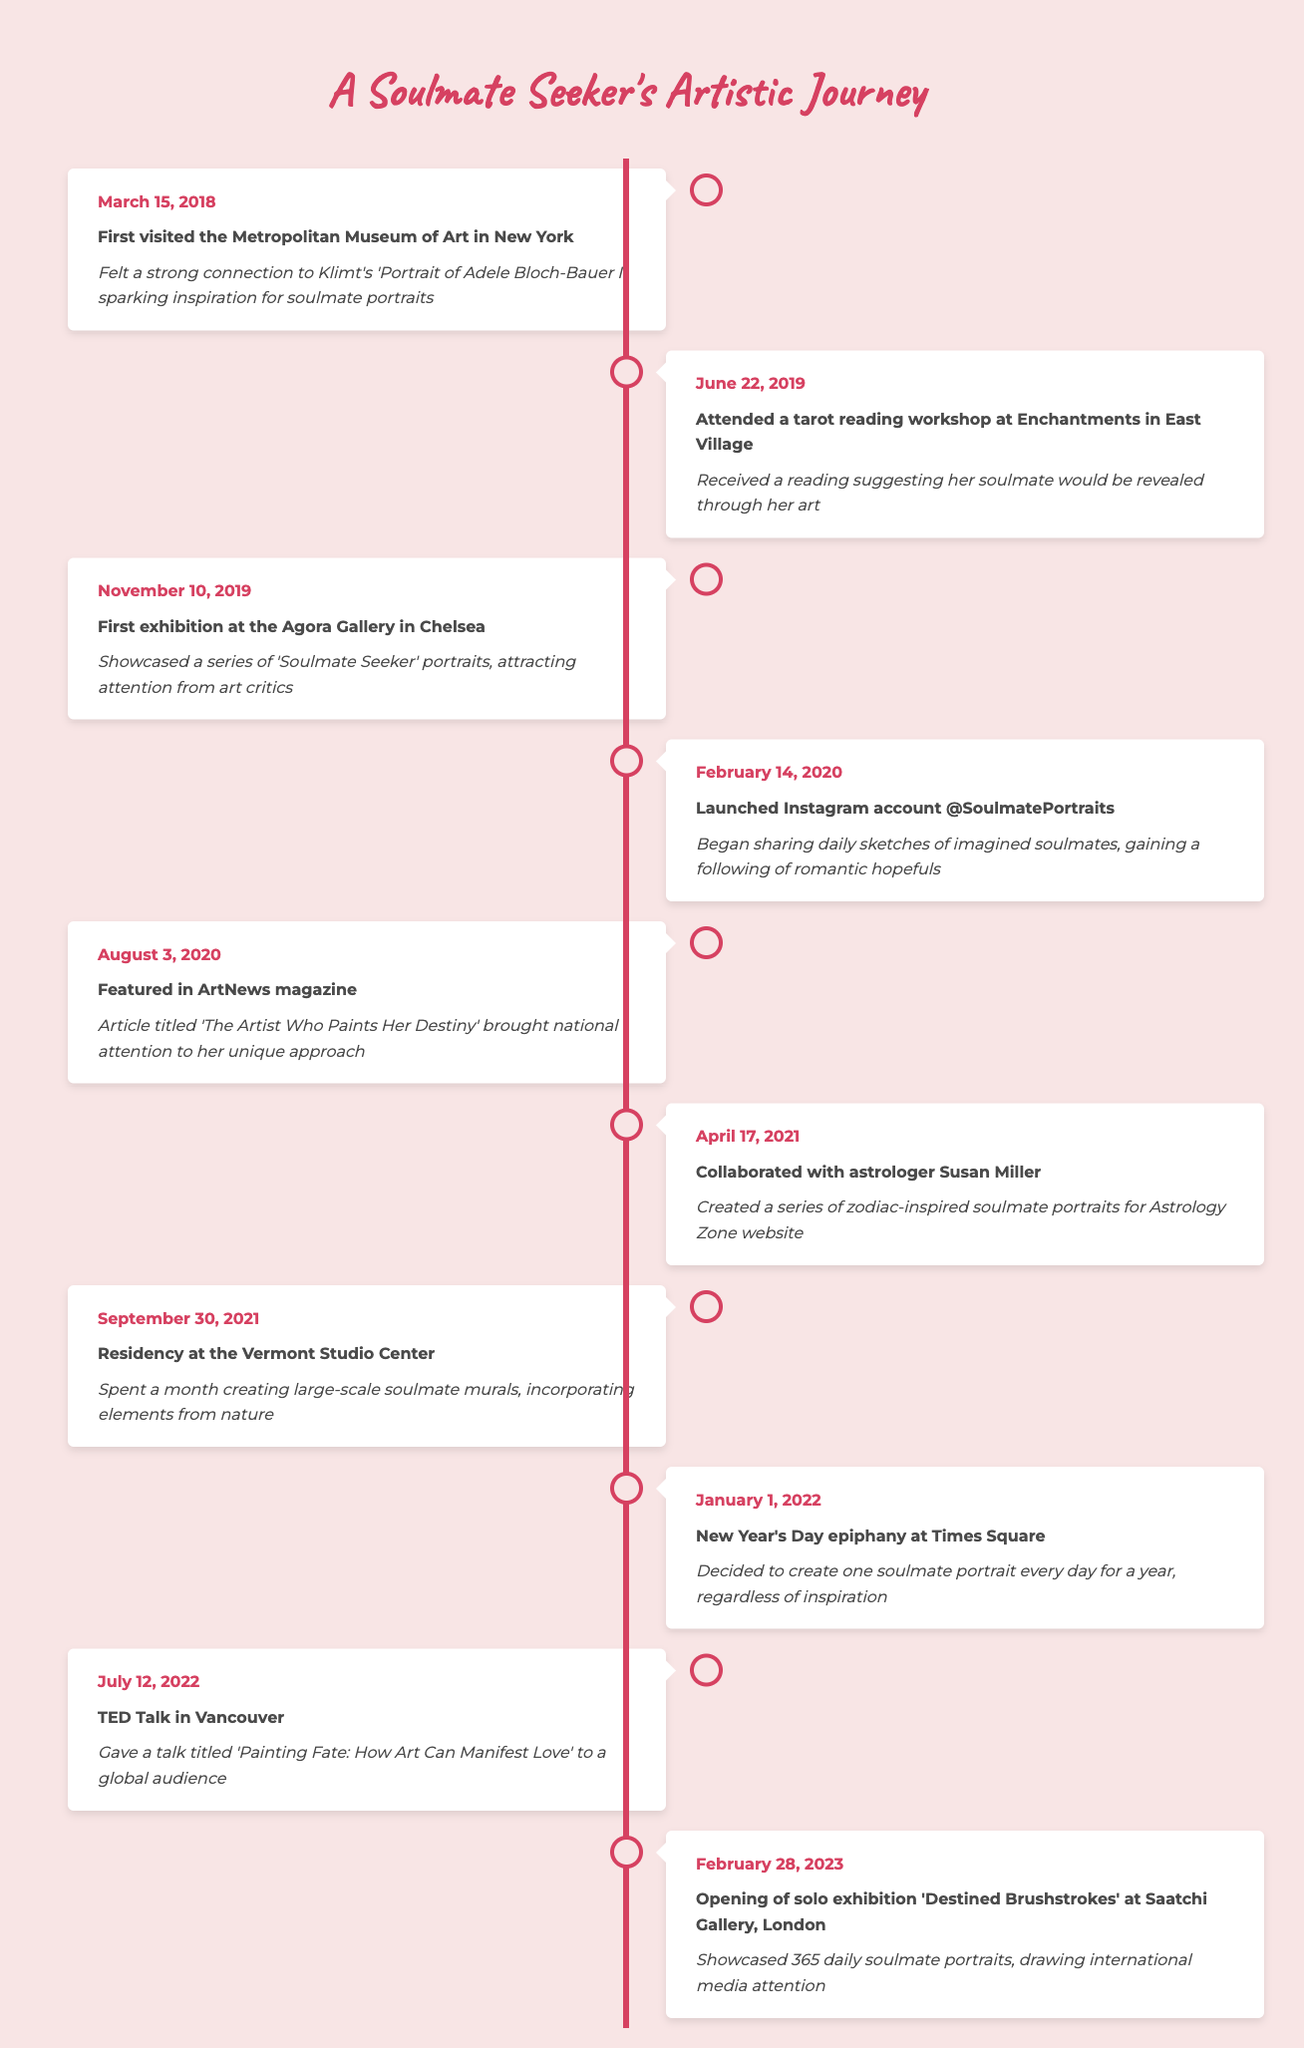What was the date of the artist's first exhibition? The table shows the artist's first exhibition date as November 10, 2019. This information can be found under the event that mentions her exhibition at the Agora Gallery in Chelsea.
Answer: November 10, 2019 Which event occurred after the launch of the Instagram account @SoulmatePortraits? The timeline shows that the Instagram account was launched on February 14, 2020, and the following event listed is the feature in ArtNews magazine on August 3, 2020. Therefore, the event that occurred after the Instagram launch is the feature in ArtNews magazine.
Answer: Feature in ArtNews magazine How many months passed between the artist's first exhibition and the TED Talk in Vancouver? The first exhibition was on November 10, 2019, and the TED Talk occurred on July 12, 2022. The number of months between these two dates can be calculated by counting the months: from November 2019 to November 2020 is 12 months, then adding the full years (2020 to 2021 is 12 months, 2021 to 2022 is another 7 months). Thus, the total is 12 + 12 + 7 = 31 months.
Answer: 31 months Did the artist create a series of zodiac-inspired soulmate portraits? Yes, the timeline indicates that on April 17, 2021, the artist collaborated with astrologer Susan Miller to create a series of zodiac-inspired soulmate portraits.
Answer: Yes What is the significance of the date January 1, 2022, in the artist's journey? According to the table, on January 1, 2022, the artist had a New Year's Day epiphany at Times Square where she decided to create one soulmate portrait every day for a year, regardless of inspiration. This decision signifies a pivotal moment in her creative process.
Answer: It was her decision to create one soulmate portrait every day for a year 